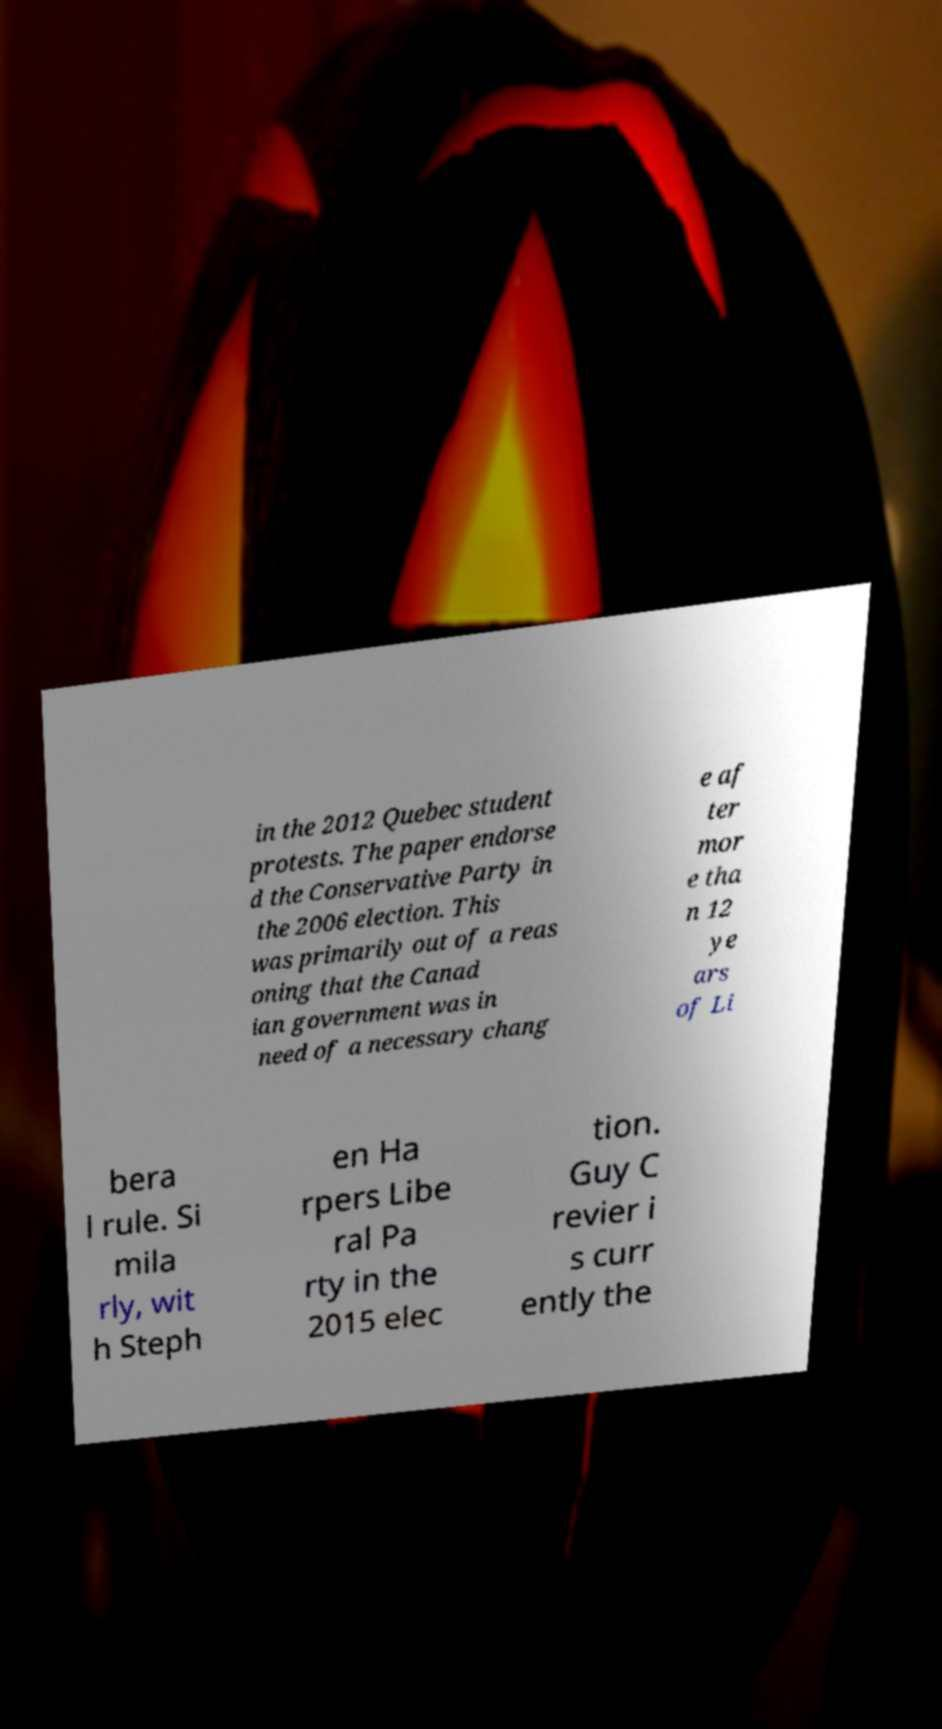Could you extract and type out the text from this image? in the 2012 Quebec student protests. The paper endorse d the Conservative Party in the 2006 election. This was primarily out of a reas oning that the Canad ian government was in need of a necessary chang e af ter mor e tha n 12 ye ars of Li bera l rule. Si mila rly, wit h Steph en Ha rpers Libe ral Pa rty in the 2015 elec tion. Guy C revier i s curr ently the 